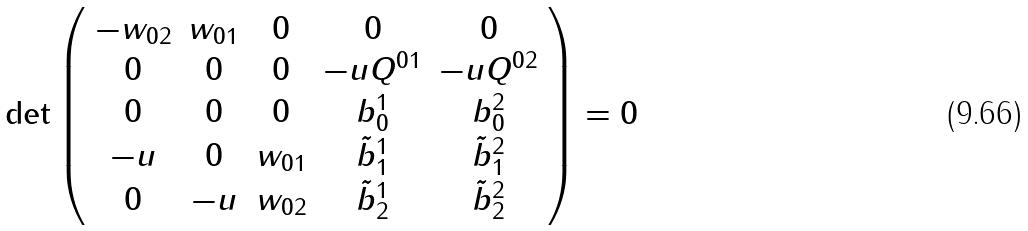<formula> <loc_0><loc_0><loc_500><loc_500>\det \left ( \begin{array} { c c c c c } - w _ { 0 2 } & w _ { 0 1 } & 0 & 0 & 0 \\ 0 & 0 & 0 & - u Q ^ { 0 1 } & - u Q ^ { 0 2 } \\ 0 & 0 & 0 & b _ { 0 } ^ { 1 } & b _ { 0 } ^ { 2 } \\ - u & 0 & w _ { 0 1 } & \tilde { b } _ { 1 } ^ { 1 } & \tilde { b } _ { 1 } ^ { 2 } \\ 0 & - u & w _ { 0 2 } & \tilde { b } _ { 2 } ^ { 1 } & \tilde { b } _ { 2 } ^ { 2 } \end{array} \right ) = 0</formula> 